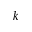Convert formula to latex. <formula><loc_0><loc_0><loc_500><loc_500>k</formula> 